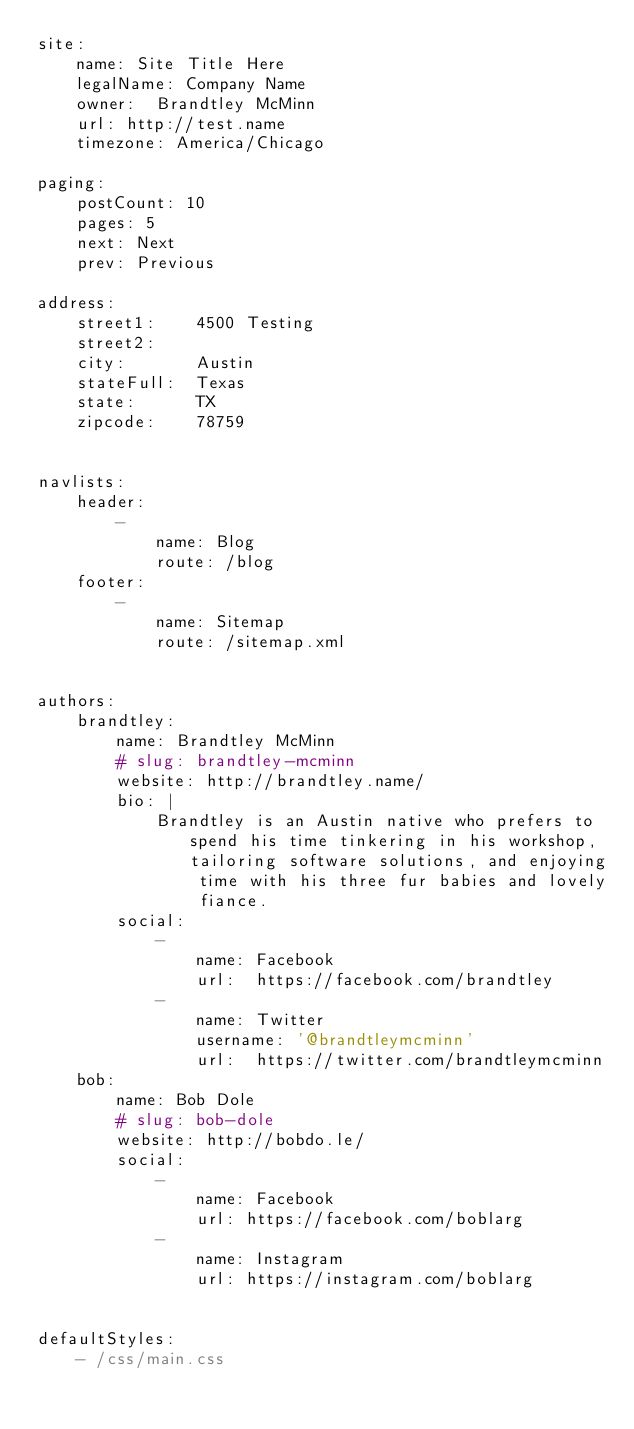<code> <loc_0><loc_0><loc_500><loc_500><_YAML_>site:
    name: Site Title Here
    legalName: Company Name
    owner:  Brandtley McMinn
    url: http://test.name
    timezone: America/Chicago

paging:
    postCount: 10
    pages: 5
    next: Next
    prev: Previous

address:
    street1:    4500 Testing
    street2:
    city:       Austin
    stateFull:  Texas
    state:      TX
    zipcode:    78759


navlists:
    header:
        -
            name: Blog
            route: /blog
    footer:
        -
            name: Sitemap
            route: /sitemap.xml


authors:
    brandtley:
        name: Brandtley McMinn
        # slug: brandtley-mcminn
        website: http://brandtley.name/
        bio: |
            Brandtley is an Austin native who prefers to spend his time tinkering in his workshop, tailoring software solutions, and enjoying time with his three fur babies and lovely fiance.
        social:
            -
                name: Facebook
                url:  https://facebook.com/brandtley
            -
                name: Twitter
                username: '@brandtleymcminn'
                url:  https://twitter.com/brandtleymcminn
    bob:
        name: Bob Dole
        # slug: bob-dole
        website: http://bobdo.le/
        social:
            -
                name: Facebook
                url: https://facebook.com/boblarg
            -
                name: Instagram
                url: https://instagram.com/boblarg


defaultStyles:
    - /css/main.css
</code> 